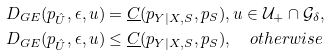Convert formula to latex. <formula><loc_0><loc_0><loc_500><loc_500>& D _ { G E } ( p _ { \hat { U } } , \epsilon , u ) = \underline { C } ( p _ { Y | X , S } , p _ { S } ) , u \in \mathcal { U } _ { + } \cap \mathcal { G } _ { \delta } , \\ & D _ { G E } ( p _ { \hat { U } } , \epsilon , u ) \leq \underline { C } ( p _ { Y | X , S } , p _ { S } ) , \quad o t h e r w i s e</formula> 